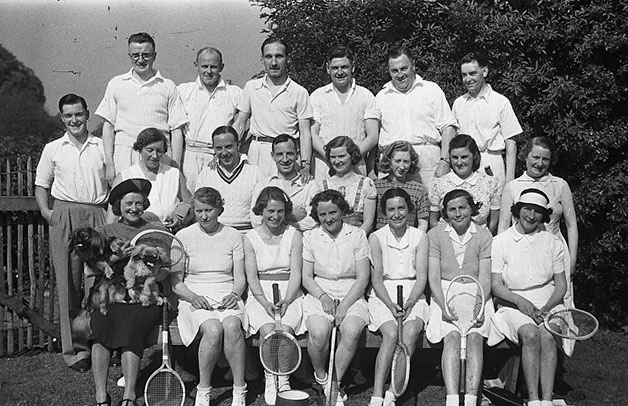Describe the objects in this image and their specific colors. I can see people in lightgray, darkgray, gray, and black tones, people in lightgray, black, gray, and darkgray tones, people in lightgray, darkgray, gray, and black tones, people in lightgray, gray, black, and darkgray tones, and people in lightgray, gainsboro, gray, darkgray, and black tones in this image. 